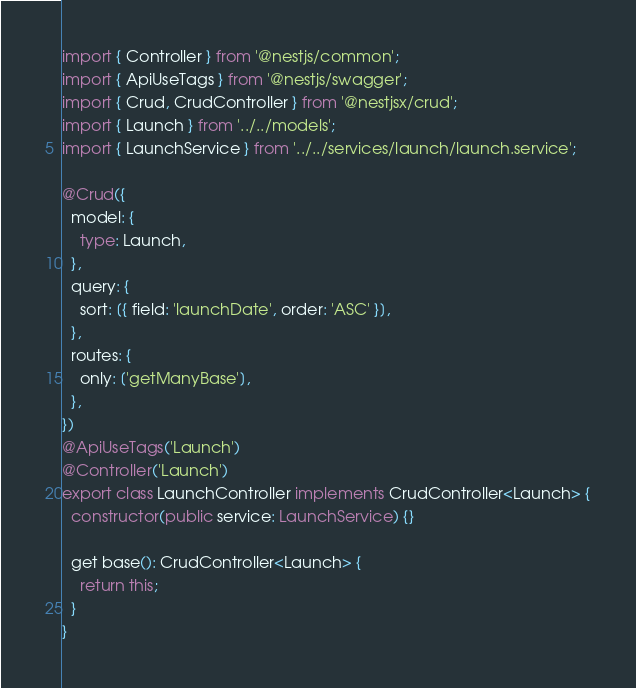<code> <loc_0><loc_0><loc_500><loc_500><_TypeScript_>import { Controller } from '@nestjs/common';
import { ApiUseTags } from '@nestjs/swagger';
import { Crud, CrudController } from '@nestjsx/crud';
import { Launch } from '../../models';
import { LaunchService } from '../../services/launch/launch.service';

@Crud({
  model: {
    type: Launch,
  },
  query: {
    sort: [{ field: 'launchDate', order: 'ASC' }],
  },
  routes: {
    only: ['getManyBase'],
  },
})
@ApiUseTags('Launch')
@Controller('Launch')
export class LaunchController implements CrudController<Launch> {
  constructor(public service: LaunchService) {}

  get base(): CrudController<Launch> {
    return this;
  }
}
</code> 